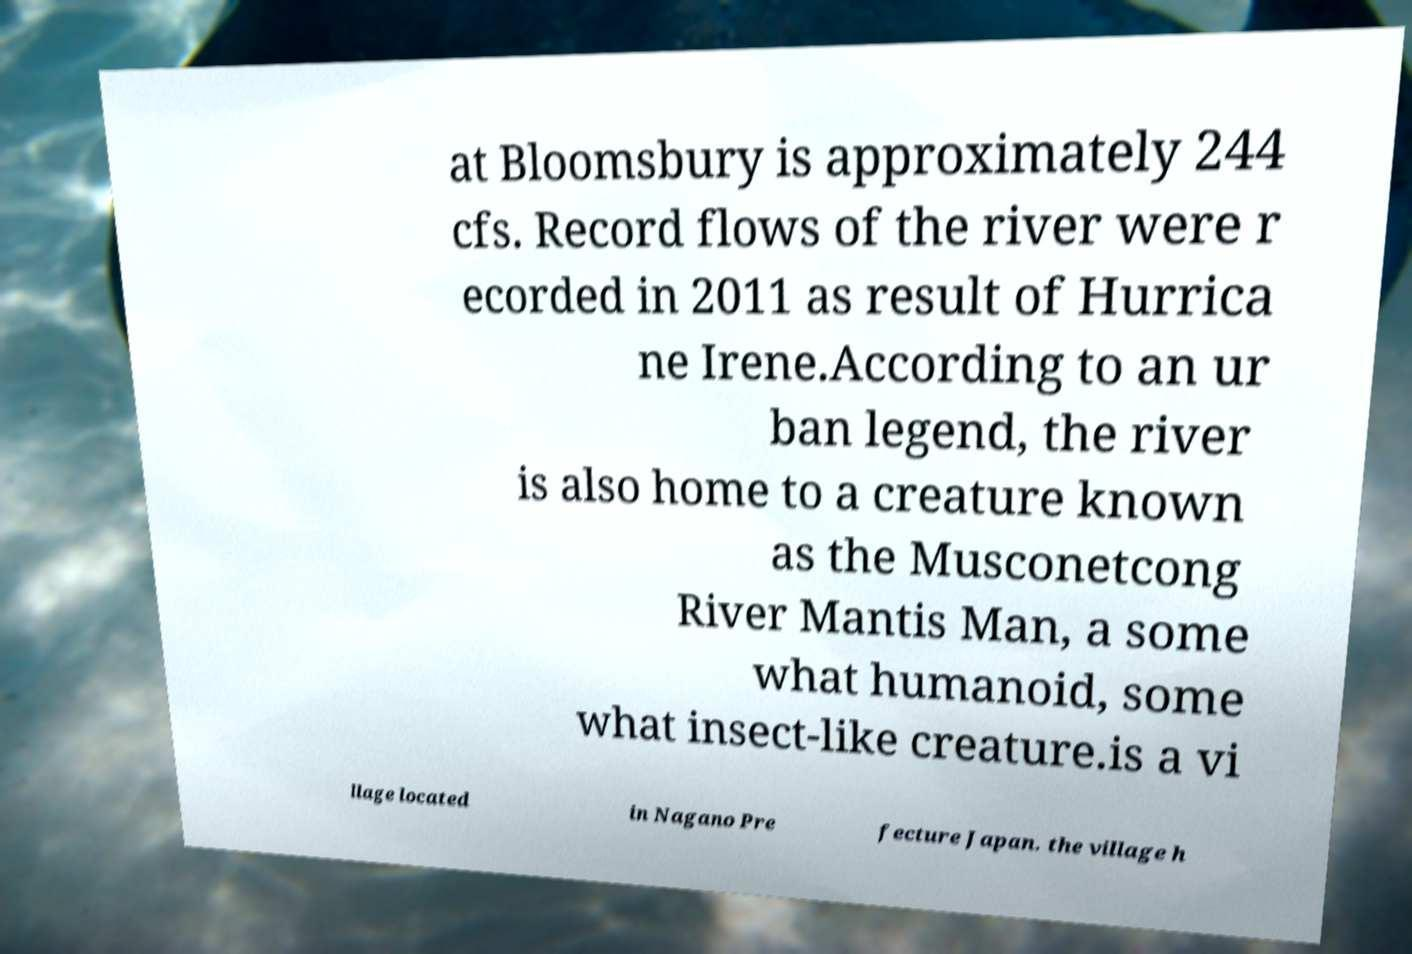Please read and relay the text visible in this image. What does it say? at Bloomsbury is approximately 244 cfs. Record flows of the river were r ecorded in 2011 as result of Hurrica ne Irene.According to an ur ban legend, the river is also home to a creature known as the Musconetcong River Mantis Man, a some what humanoid, some what insect-like creature.is a vi llage located in Nagano Pre fecture Japan. the village h 